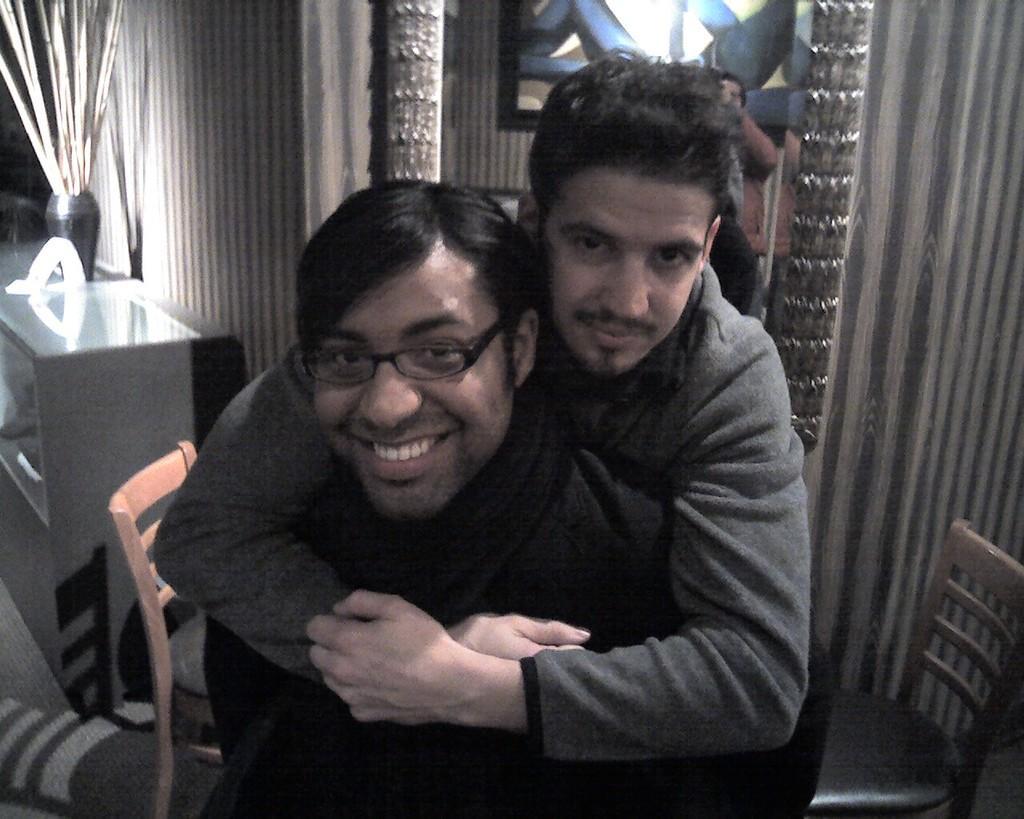In one or two sentences, can you explain what this image depicts? In the center of the image there are two people where the man in the front is smiling and the man in the back is holding him. In the background there is a table and a decor placed on the table. We can also see some curtains and chairs. 